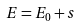Convert formula to latex. <formula><loc_0><loc_0><loc_500><loc_500>E = E _ { 0 } + s</formula> 